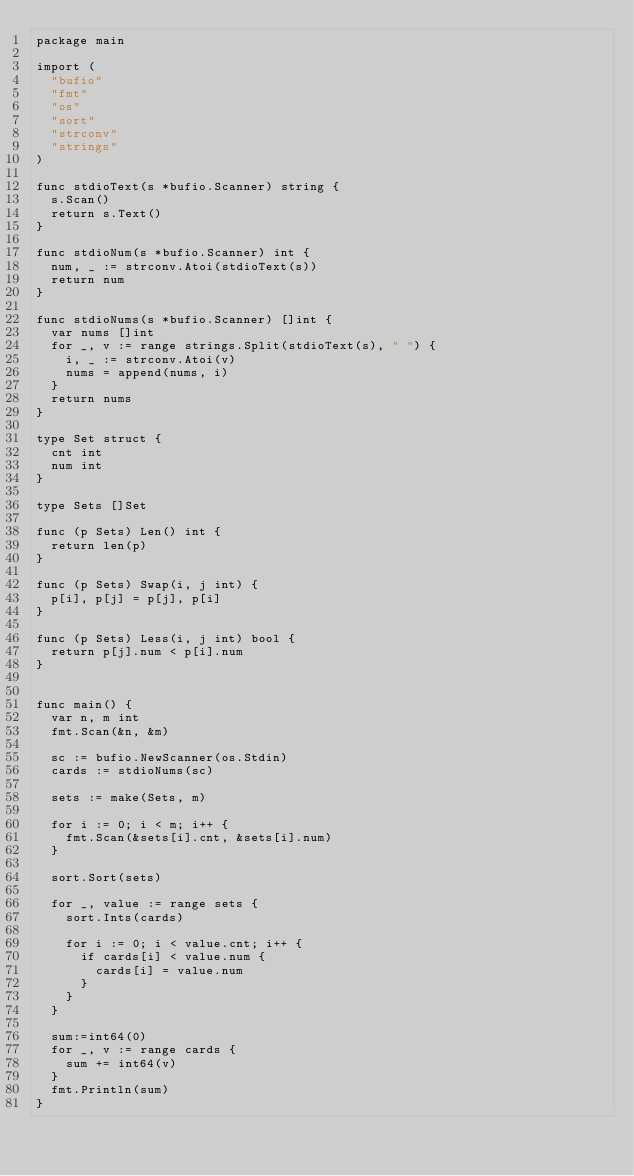<code> <loc_0><loc_0><loc_500><loc_500><_Go_>package main

import (
	"bufio"
	"fmt"
	"os"
	"sort"
	"strconv"
	"strings"
)

func stdioText(s *bufio.Scanner) string {
	s.Scan()
	return s.Text()
}

func stdioNum(s *bufio.Scanner) int {
	num, _ := strconv.Atoi(stdioText(s))
	return num
}

func stdioNums(s *bufio.Scanner) []int {
	var nums []int
	for _, v := range strings.Split(stdioText(s), " ") {
		i, _ := strconv.Atoi(v)
		nums = append(nums, i)
	}
	return nums
}

type Set struct {
	cnt int
	num int
}

type Sets []Set

func (p Sets) Len() int {
	return len(p)
}

func (p Sets) Swap(i, j int) {
	p[i], p[j] = p[j], p[i]
}

func (p Sets) Less(i, j int) bool {
	return p[j].num < p[i].num
}


func main() {
	var n, m int
	fmt.Scan(&n, &m)

	sc := bufio.NewScanner(os.Stdin)
	cards := stdioNums(sc)

	sets := make(Sets, m)

	for i := 0; i < m; i++ {
		fmt.Scan(&sets[i].cnt, &sets[i].num)
	}

	sort.Sort(sets)

	for _, value := range sets {
		sort.Ints(cards)

		for i := 0; i < value.cnt; i++ {
			if cards[i] < value.num {
				cards[i] = value.num
			}
		}
	}

	sum:=int64(0)
	for _, v := range cards {
		sum += int64(v)
	}
	fmt.Println(sum)
}
</code> 